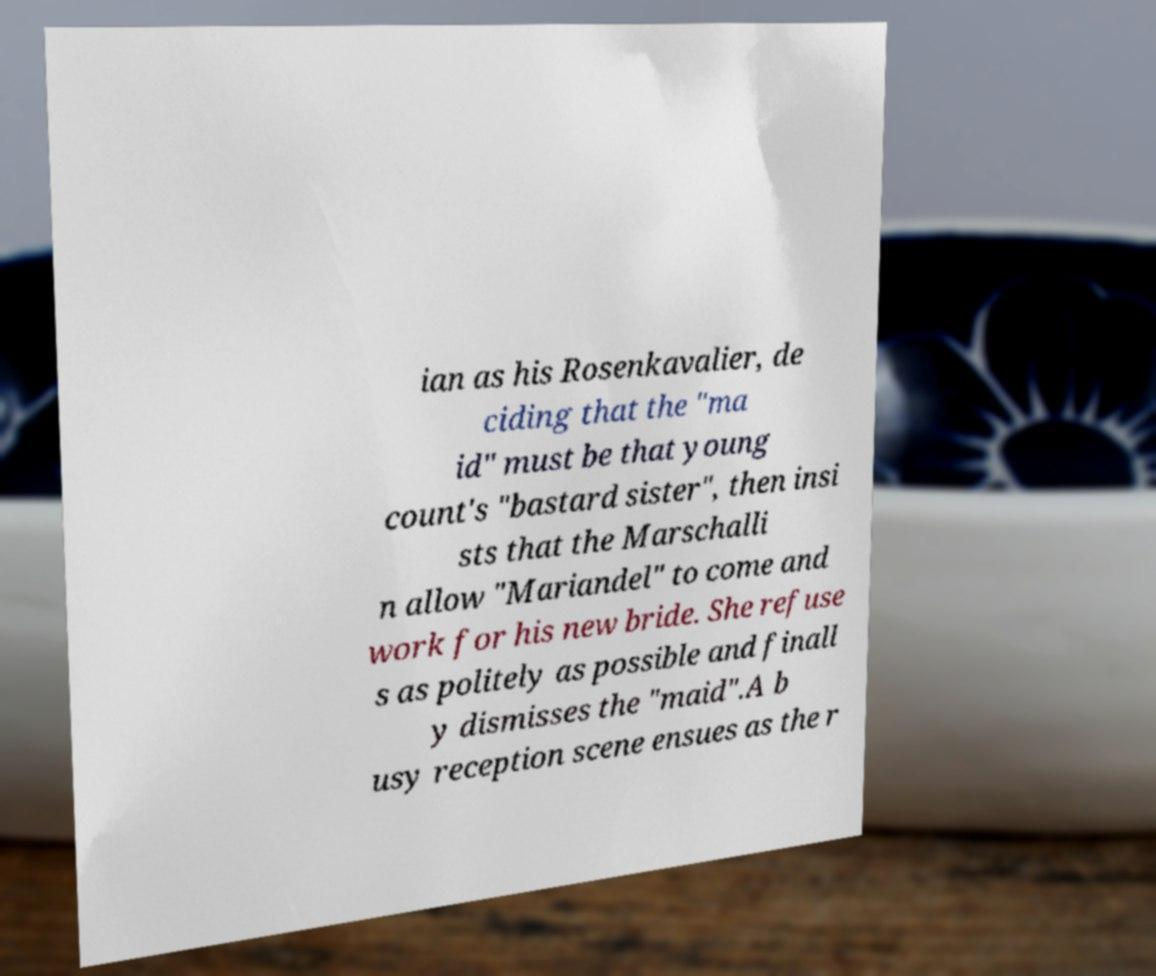I need the written content from this picture converted into text. Can you do that? ian as his Rosenkavalier, de ciding that the "ma id" must be that young count's "bastard sister", then insi sts that the Marschalli n allow "Mariandel" to come and work for his new bride. She refuse s as politely as possible and finall y dismisses the "maid".A b usy reception scene ensues as the r 